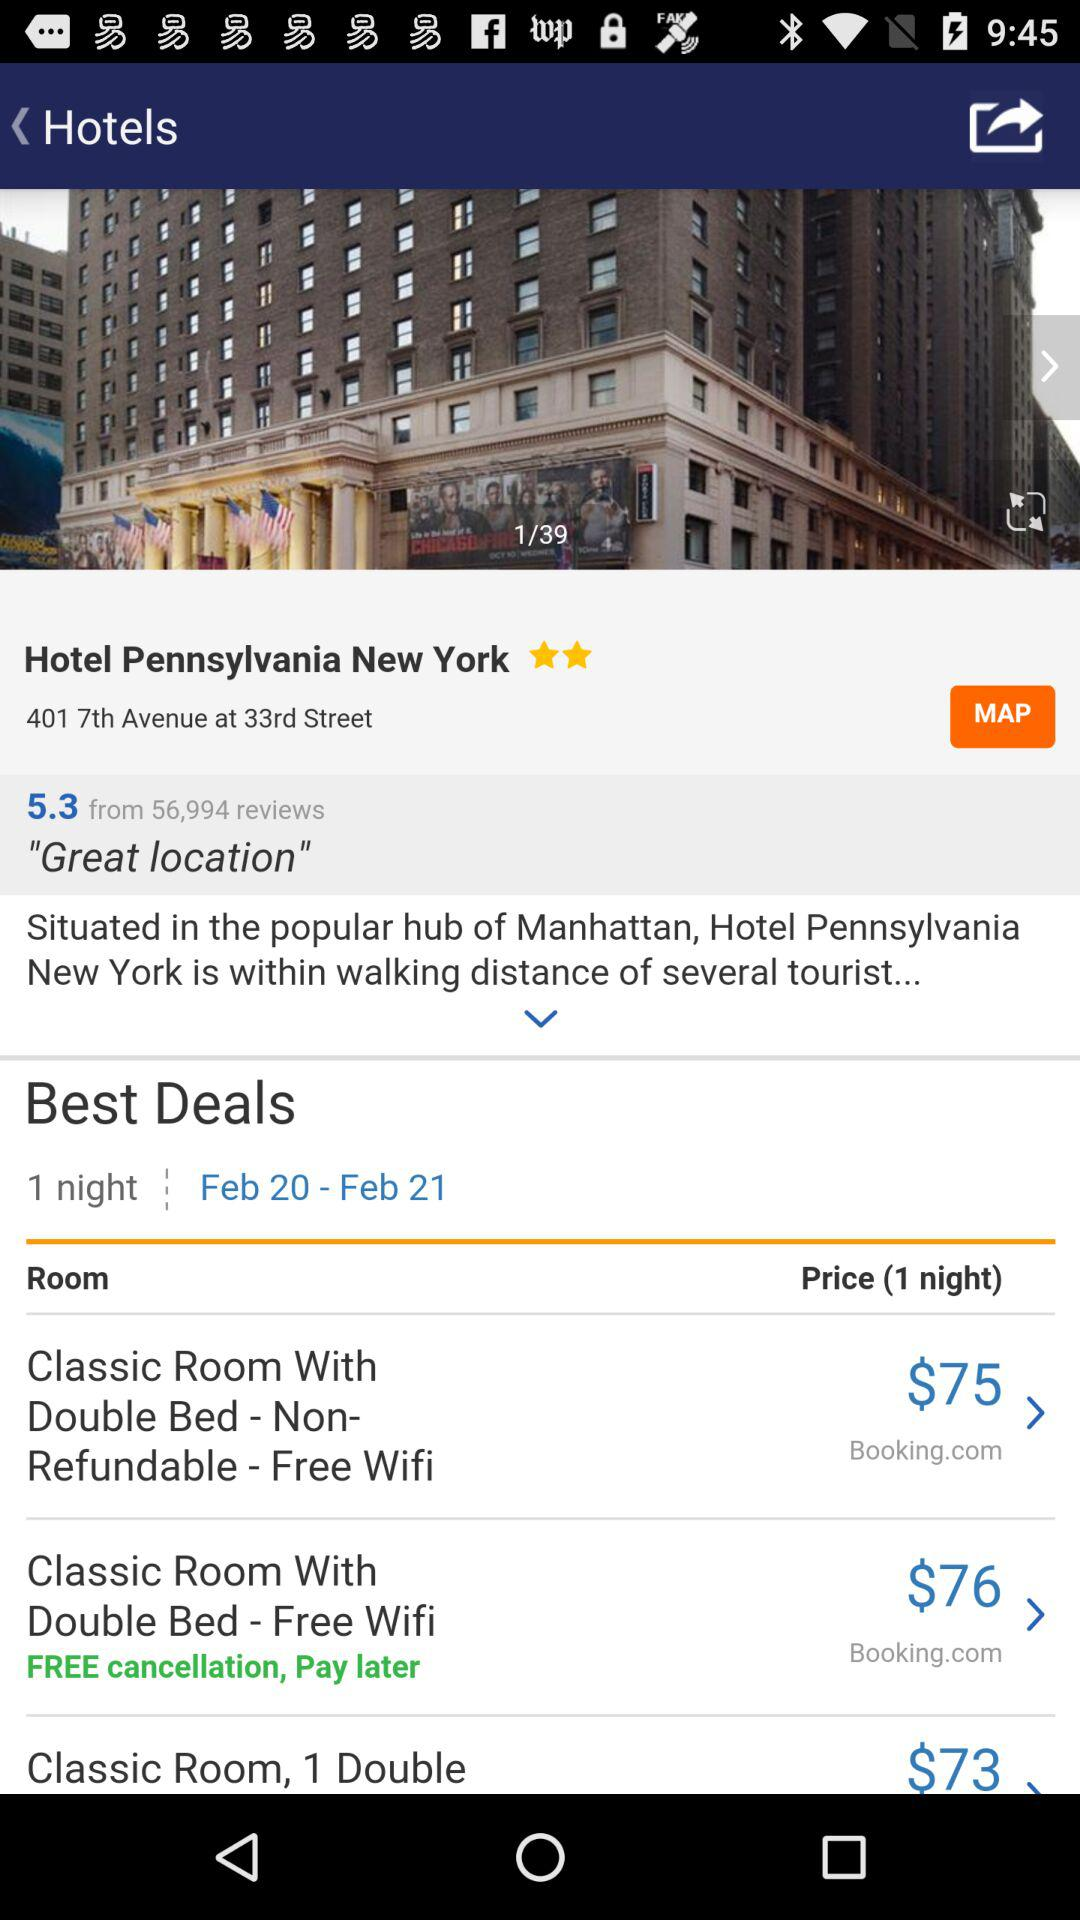What room has a free cancellation option? The room is "Classic Room With Double Bed - Free Wifi". 